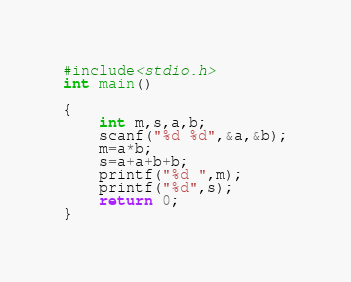Convert code to text. <code><loc_0><loc_0><loc_500><loc_500><_C_>#include<stdio.h>
int main()

{
    int m,s,a,b;
    scanf("%d %d",&a,&b);
    m=a*b;
    s=a+a+b+b;
    printf("%d ",m);
    printf("%d",s);
    return 0;
}</code> 